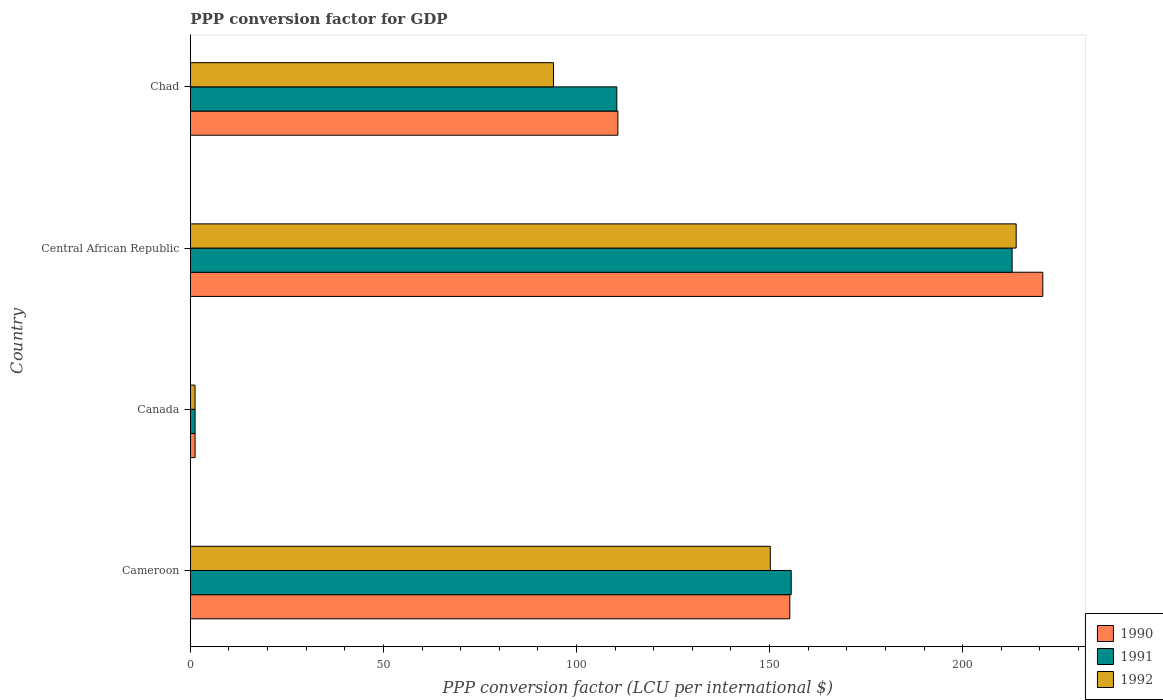How many groups of bars are there?
Provide a short and direct response. 4. Are the number of bars per tick equal to the number of legend labels?
Provide a short and direct response. Yes. In how many cases, is the number of bars for a given country not equal to the number of legend labels?
Ensure brevity in your answer.  0. What is the PPP conversion factor for GDP in 1992 in Canada?
Provide a short and direct response. 1.23. Across all countries, what is the maximum PPP conversion factor for GDP in 1990?
Offer a very short reply. 220.76. Across all countries, what is the minimum PPP conversion factor for GDP in 1990?
Make the answer very short. 1.24. In which country was the PPP conversion factor for GDP in 1990 maximum?
Make the answer very short. Central African Republic. What is the total PPP conversion factor for GDP in 1991 in the graph?
Offer a very short reply. 480.1. What is the difference between the PPP conversion factor for GDP in 1992 in Canada and that in Central African Republic?
Make the answer very short. -212.63. What is the difference between the PPP conversion factor for GDP in 1990 in Canada and the PPP conversion factor for GDP in 1991 in Chad?
Your answer should be very brief. -109.2. What is the average PPP conversion factor for GDP in 1991 per country?
Ensure brevity in your answer.  120.03. What is the difference between the PPP conversion factor for GDP in 1991 and PPP conversion factor for GDP in 1990 in Central African Republic?
Your response must be concise. -7.94. What is the ratio of the PPP conversion factor for GDP in 1992 in Canada to that in Central African Republic?
Your answer should be very brief. 0.01. Is the difference between the PPP conversion factor for GDP in 1991 in Cameroon and Canada greater than the difference between the PPP conversion factor for GDP in 1990 in Cameroon and Canada?
Offer a very short reply. Yes. What is the difference between the highest and the second highest PPP conversion factor for GDP in 1991?
Provide a short and direct response. 57.21. What is the difference between the highest and the lowest PPP conversion factor for GDP in 1990?
Offer a terse response. 219.51. Is it the case that in every country, the sum of the PPP conversion factor for GDP in 1992 and PPP conversion factor for GDP in 1990 is greater than the PPP conversion factor for GDP in 1991?
Ensure brevity in your answer.  Yes. How many bars are there?
Your answer should be compact. 12. Are all the bars in the graph horizontal?
Give a very brief answer. Yes. How many countries are there in the graph?
Keep it short and to the point. 4. Does the graph contain any zero values?
Ensure brevity in your answer.  No. How are the legend labels stacked?
Provide a short and direct response. Vertical. What is the title of the graph?
Your answer should be very brief. PPP conversion factor for GDP. What is the label or title of the X-axis?
Offer a very short reply. PPP conversion factor (LCU per international $). What is the PPP conversion factor (LCU per international $) in 1990 in Cameroon?
Ensure brevity in your answer.  155.24. What is the PPP conversion factor (LCU per international $) in 1991 in Cameroon?
Provide a succinct answer. 155.6. What is the PPP conversion factor (LCU per international $) in 1992 in Cameroon?
Offer a terse response. 150.19. What is the PPP conversion factor (LCU per international $) in 1990 in Canada?
Provide a succinct answer. 1.24. What is the PPP conversion factor (LCU per international $) of 1991 in Canada?
Offer a very short reply. 1.24. What is the PPP conversion factor (LCU per international $) in 1992 in Canada?
Offer a terse response. 1.23. What is the PPP conversion factor (LCU per international $) in 1990 in Central African Republic?
Your answer should be very brief. 220.76. What is the PPP conversion factor (LCU per international $) of 1991 in Central African Republic?
Your response must be concise. 212.81. What is the PPP conversion factor (LCU per international $) in 1992 in Central African Republic?
Your response must be concise. 213.86. What is the PPP conversion factor (LCU per international $) of 1990 in Chad?
Provide a short and direct response. 110.72. What is the PPP conversion factor (LCU per international $) of 1991 in Chad?
Provide a short and direct response. 110.45. What is the PPP conversion factor (LCU per international $) of 1992 in Chad?
Your response must be concise. 94.05. Across all countries, what is the maximum PPP conversion factor (LCU per international $) of 1990?
Provide a short and direct response. 220.76. Across all countries, what is the maximum PPP conversion factor (LCU per international $) of 1991?
Offer a very short reply. 212.81. Across all countries, what is the maximum PPP conversion factor (LCU per international $) in 1992?
Provide a succinct answer. 213.86. Across all countries, what is the minimum PPP conversion factor (LCU per international $) in 1990?
Your answer should be compact. 1.24. Across all countries, what is the minimum PPP conversion factor (LCU per international $) of 1991?
Keep it short and to the point. 1.24. Across all countries, what is the minimum PPP conversion factor (LCU per international $) in 1992?
Ensure brevity in your answer.  1.23. What is the total PPP conversion factor (LCU per international $) in 1990 in the graph?
Your response must be concise. 487.96. What is the total PPP conversion factor (LCU per international $) in 1991 in the graph?
Your response must be concise. 480.1. What is the total PPP conversion factor (LCU per international $) in 1992 in the graph?
Ensure brevity in your answer.  459.33. What is the difference between the PPP conversion factor (LCU per international $) in 1990 in Cameroon and that in Canada?
Provide a short and direct response. 154. What is the difference between the PPP conversion factor (LCU per international $) in 1991 in Cameroon and that in Canada?
Offer a very short reply. 154.37. What is the difference between the PPP conversion factor (LCU per international $) of 1992 in Cameroon and that in Canada?
Offer a very short reply. 148.96. What is the difference between the PPP conversion factor (LCU per international $) of 1990 in Cameroon and that in Central African Republic?
Your response must be concise. -65.51. What is the difference between the PPP conversion factor (LCU per international $) of 1991 in Cameroon and that in Central African Republic?
Your answer should be compact. -57.21. What is the difference between the PPP conversion factor (LCU per international $) of 1992 in Cameroon and that in Central African Republic?
Provide a succinct answer. -63.67. What is the difference between the PPP conversion factor (LCU per international $) of 1990 in Cameroon and that in Chad?
Provide a succinct answer. 44.52. What is the difference between the PPP conversion factor (LCU per international $) in 1991 in Cameroon and that in Chad?
Provide a short and direct response. 45.16. What is the difference between the PPP conversion factor (LCU per international $) in 1992 in Cameroon and that in Chad?
Provide a succinct answer. 56.15. What is the difference between the PPP conversion factor (LCU per international $) in 1990 in Canada and that in Central African Republic?
Keep it short and to the point. -219.51. What is the difference between the PPP conversion factor (LCU per international $) of 1991 in Canada and that in Central African Republic?
Offer a very short reply. -211.57. What is the difference between the PPP conversion factor (LCU per international $) of 1992 in Canada and that in Central African Republic?
Ensure brevity in your answer.  -212.63. What is the difference between the PPP conversion factor (LCU per international $) of 1990 in Canada and that in Chad?
Your response must be concise. -109.48. What is the difference between the PPP conversion factor (LCU per international $) in 1991 in Canada and that in Chad?
Give a very brief answer. -109.21. What is the difference between the PPP conversion factor (LCU per international $) of 1992 in Canada and that in Chad?
Your answer should be compact. -92.82. What is the difference between the PPP conversion factor (LCU per international $) in 1990 in Central African Republic and that in Chad?
Offer a very short reply. 110.04. What is the difference between the PPP conversion factor (LCU per international $) in 1991 in Central African Republic and that in Chad?
Offer a terse response. 102.37. What is the difference between the PPP conversion factor (LCU per international $) of 1992 in Central African Republic and that in Chad?
Provide a short and direct response. 119.81. What is the difference between the PPP conversion factor (LCU per international $) of 1990 in Cameroon and the PPP conversion factor (LCU per international $) of 1991 in Canada?
Ensure brevity in your answer.  154.01. What is the difference between the PPP conversion factor (LCU per international $) in 1990 in Cameroon and the PPP conversion factor (LCU per international $) in 1992 in Canada?
Your answer should be very brief. 154.01. What is the difference between the PPP conversion factor (LCU per international $) of 1991 in Cameroon and the PPP conversion factor (LCU per international $) of 1992 in Canada?
Ensure brevity in your answer.  154.38. What is the difference between the PPP conversion factor (LCU per international $) in 1990 in Cameroon and the PPP conversion factor (LCU per international $) in 1991 in Central African Republic?
Provide a succinct answer. -57.57. What is the difference between the PPP conversion factor (LCU per international $) in 1990 in Cameroon and the PPP conversion factor (LCU per international $) in 1992 in Central African Republic?
Keep it short and to the point. -58.62. What is the difference between the PPP conversion factor (LCU per international $) in 1991 in Cameroon and the PPP conversion factor (LCU per international $) in 1992 in Central African Republic?
Offer a very short reply. -58.25. What is the difference between the PPP conversion factor (LCU per international $) of 1990 in Cameroon and the PPP conversion factor (LCU per international $) of 1991 in Chad?
Make the answer very short. 44.8. What is the difference between the PPP conversion factor (LCU per international $) of 1990 in Cameroon and the PPP conversion factor (LCU per international $) of 1992 in Chad?
Offer a very short reply. 61.2. What is the difference between the PPP conversion factor (LCU per international $) in 1991 in Cameroon and the PPP conversion factor (LCU per international $) in 1992 in Chad?
Make the answer very short. 61.56. What is the difference between the PPP conversion factor (LCU per international $) in 1990 in Canada and the PPP conversion factor (LCU per international $) in 1991 in Central African Republic?
Keep it short and to the point. -211.57. What is the difference between the PPP conversion factor (LCU per international $) of 1990 in Canada and the PPP conversion factor (LCU per international $) of 1992 in Central African Republic?
Keep it short and to the point. -212.62. What is the difference between the PPP conversion factor (LCU per international $) in 1991 in Canada and the PPP conversion factor (LCU per international $) in 1992 in Central African Republic?
Keep it short and to the point. -212.62. What is the difference between the PPP conversion factor (LCU per international $) in 1990 in Canada and the PPP conversion factor (LCU per international $) in 1991 in Chad?
Provide a succinct answer. -109.2. What is the difference between the PPP conversion factor (LCU per international $) of 1990 in Canada and the PPP conversion factor (LCU per international $) of 1992 in Chad?
Provide a succinct answer. -92.81. What is the difference between the PPP conversion factor (LCU per international $) of 1991 in Canada and the PPP conversion factor (LCU per international $) of 1992 in Chad?
Give a very brief answer. -92.81. What is the difference between the PPP conversion factor (LCU per international $) of 1990 in Central African Republic and the PPP conversion factor (LCU per international $) of 1991 in Chad?
Your answer should be very brief. 110.31. What is the difference between the PPP conversion factor (LCU per international $) of 1990 in Central African Republic and the PPP conversion factor (LCU per international $) of 1992 in Chad?
Ensure brevity in your answer.  126.71. What is the difference between the PPP conversion factor (LCU per international $) in 1991 in Central African Republic and the PPP conversion factor (LCU per international $) in 1992 in Chad?
Your answer should be very brief. 118.76. What is the average PPP conversion factor (LCU per international $) of 1990 per country?
Your answer should be very brief. 121.99. What is the average PPP conversion factor (LCU per international $) in 1991 per country?
Offer a terse response. 120.03. What is the average PPP conversion factor (LCU per international $) of 1992 per country?
Offer a very short reply. 114.83. What is the difference between the PPP conversion factor (LCU per international $) of 1990 and PPP conversion factor (LCU per international $) of 1991 in Cameroon?
Provide a short and direct response. -0.36. What is the difference between the PPP conversion factor (LCU per international $) in 1990 and PPP conversion factor (LCU per international $) in 1992 in Cameroon?
Offer a terse response. 5.05. What is the difference between the PPP conversion factor (LCU per international $) in 1991 and PPP conversion factor (LCU per international $) in 1992 in Cameroon?
Provide a succinct answer. 5.41. What is the difference between the PPP conversion factor (LCU per international $) of 1990 and PPP conversion factor (LCU per international $) of 1991 in Canada?
Your response must be concise. 0. What is the difference between the PPP conversion factor (LCU per international $) of 1990 and PPP conversion factor (LCU per international $) of 1992 in Canada?
Your answer should be very brief. 0.01. What is the difference between the PPP conversion factor (LCU per international $) of 1991 and PPP conversion factor (LCU per international $) of 1992 in Canada?
Offer a very short reply. 0.01. What is the difference between the PPP conversion factor (LCU per international $) of 1990 and PPP conversion factor (LCU per international $) of 1991 in Central African Republic?
Your response must be concise. 7.94. What is the difference between the PPP conversion factor (LCU per international $) in 1990 and PPP conversion factor (LCU per international $) in 1992 in Central African Republic?
Provide a succinct answer. 6.9. What is the difference between the PPP conversion factor (LCU per international $) of 1991 and PPP conversion factor (LCU per international $) of 1992 in Central African Republic?
Keep it short and to the point. -1.05. What is the difference between the PPP conversion factor (LCU per international $) in 1990 and PPP conversion factor (LCU per international $) in 1991 in Chad?
Offer a very short reply. 0.27. What is the difference between the PPP conversion factor (LCU per international $) of 1990 and PPP conversion factor (LCU per international $) of 1992 in Chad?
Ensure brevity in your answer.  16.67. What is the difference between the PPP conversion factor (LCU per international $) in 1991 and PPP conversion factor (LCU per international $) in 1992 in Chad?
Your answer should be compact. 16.4. What is the ratio of the PPP conversion factor (LCU per international $) in 1990 in Cameroon to that in Canada?
Offer a terse response. 125.04. What is the ratio of the PPP conversion factor (LCU per international $) of 1991 in Cameroon to that in Canada?
Your answer should be compact. 125.64. What is the ratio of the PPP conversion factor (LCU per international $) in 1992 in Cameroon to that in Canada?
Provide a short and direct response. 122.22. What is the ratio of the PPP conversion factor (LCU per international $) of 1990 in Cameroon to that in Central African Republic?
Offer a terse response. 0.7. What is the ratio of the PPP conversion factor (LCU per international $) of 1991 in Cameroon to that in Central African Republic?
Provide a short and direct response. 0.73. What is the ratio of the PPP conversion factor (LCU per international $) of 1992 in Cameroon to that in Central African Republic?
Make the answer very short. 0.7. What is the ratio of the PPP conversion factor (LCU per international $) in 1990 in Cameroon to that in Chad?
Offer a very short reply. 1.4. What is the ratio of the PPP conversion factor (LCU per international $) in 1991 in Cameroon to that in Chad?
Provide a short and direct response. 1.41. What is the ratio of the PPP conversion factor (LCU per international $) of 1992 in Cameroon to that in Chad?
Your answer should be very brief. 1.6. What is the ratio of the PPP conversion factor (LCU per international $) in 1990 in Canada to that in Central African Republic?
Ensure brevity in your answer.  0.01. What is the ratio of the PPP conversion factor (LCU per international $) in 1991 in Canada to that in Central African Republic?
Offer a terse response. 0.01. What is the ratio of the PPP conversion factor (LCU per international $) of 1992 in Canada to that in Central African Republic?
Give a very brief answer. 0.01. What is the ratio of the PPP conversion factor (LCU per international $) in 1990 in Canada to that in Chad?
Offer a terse response. 0.01. What is the ratio of the PPP conversion factor (LCU per international $) of 1991 in Canada to that in Chad?
Provide a succinct answer. 0.01. What is the ratio of the PPP conversion factor (LCU per international $) of 1992 in Canada to that in Chad?
Your response must be concise. 0.01. What is the ratio of the PPP conversion factor (LCU per international $) of 1990 in Central African Republic to that in Chad?
Ensure brevity in your answer.  1.99. What is the ratio of the PPP conversion factor (LCU per international $) of 1991 in Central African Republic to that in Chad?
Your answer should be very brief. 1.93. What is the ratio of the PPP conversion factor (LCU per international $) of 1992 in Central African Republic to that in Chad?
Keep it short and to the point. 2.27. What is the difference between the highest and the second highest PPP conversion factor (LCU per international $) in 1990?
Your response must be concise. 65.51. What is the difference between the highest and the second highest PPP conversion factor (LCU per international $) in 1991?
Your answer should be compact. 57.21. What is the difference between the highest and the second highest PPP conversion factor (LCU per international $) in 1992?
Provide a short and direct response. 63.67. What is the difference between the highest and the lowest PPP conversion factor (LCU per international $) in 1990?
Offer a very short reply. 219.51. What is the difference between the highest and the lowest PPP conversion factor (LCU per international $) of 1991?
Offer a terse response. 211.57. What is the difference between the highest and the lowest PPP conversion factor (LCU per international $) in 1992?
Give a very brief answer. 212.63. 